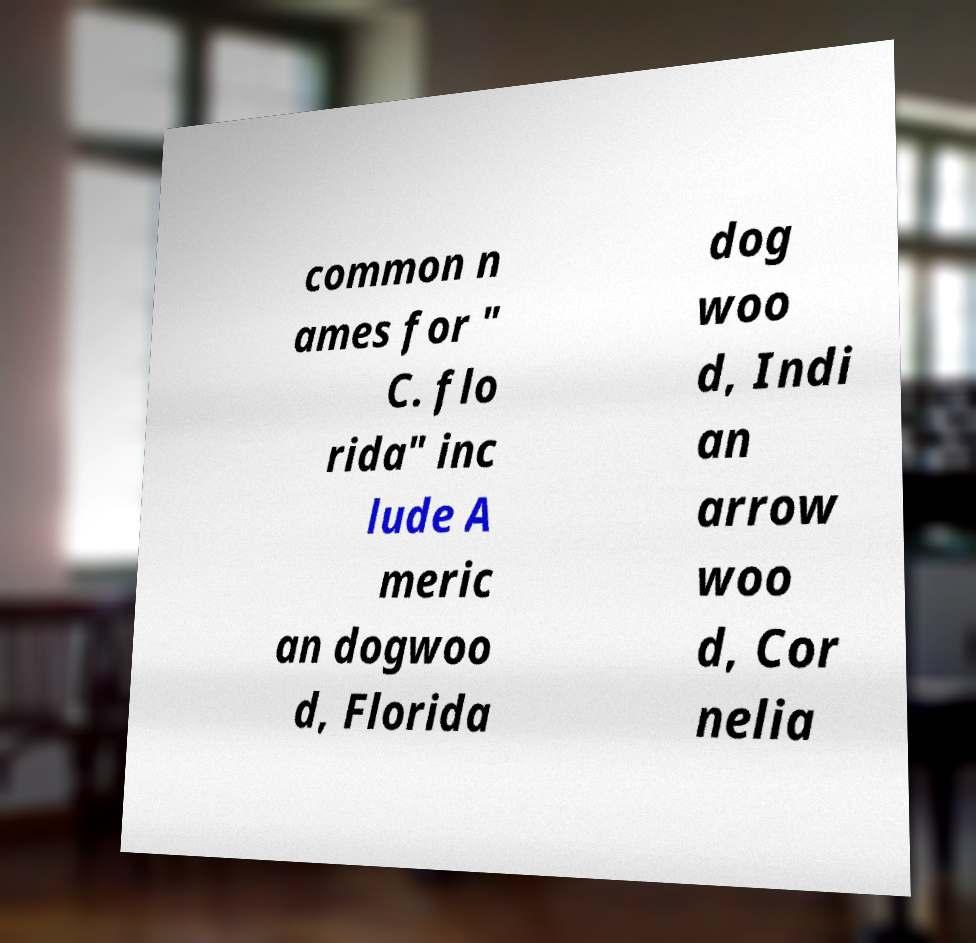Please read and relay the text visible in this image. What does it say? common n ames for " C. flo rida" inc lude A meric an dogwoo d, Florida dog woo d, Indi an arrow woo d, Cor nelia 